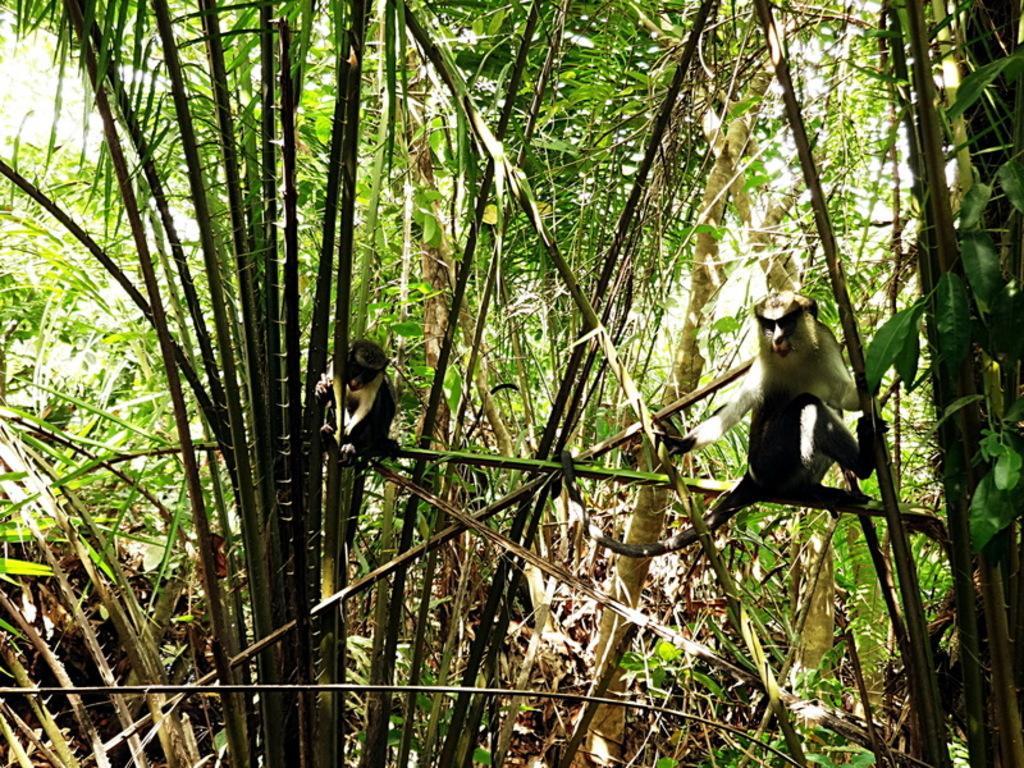Describe this image in one or two sentences. In this image I can see number of trees and here I can see two monkeys. 